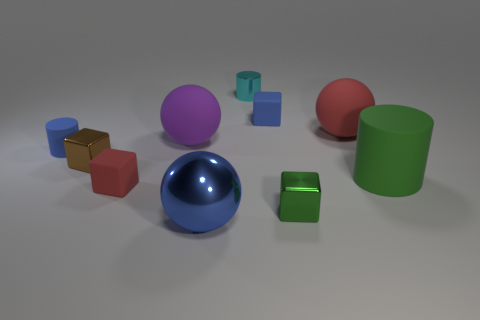How many other things are made of the same material as the large green thing?
Your answer should be very brief. 5. What is the color of the other rubber object that is the same shape as the purple rubber thing?
Provide a short and direct response. Red. Is the large purple rubber object the same shape as the large red object?
Provide a short and direct response. Yes. How many balls are either purple matte things or large metallic things?
Your answer should be compact. 2. There is a small cylinder that is made of the same material as the large green object; what is its color?
Your answer should be compact. Blue. Is the size of the blue rubber object right of the blue ball the same as the small cyan metallic object?
Offer a very short reply. Yes. Is the material of the purple thing the same as the blue object on the left side of the big blue sphere?
Your answer should be very brief. Yes. The small metal block that is on the left side of the metal ball is what color?
Ensure brevity in your answer.  Brown. Is there a blue matte cylinder that is on the left side of the small metallic cube in front of the small brown object?
Provide a short and direct response. Yes. Is the color of the rubber block that is behind the big red matte object the same as the rubber cylinder that is on the left side of the big metal thing?
Provide a succinct answer. Yes. 